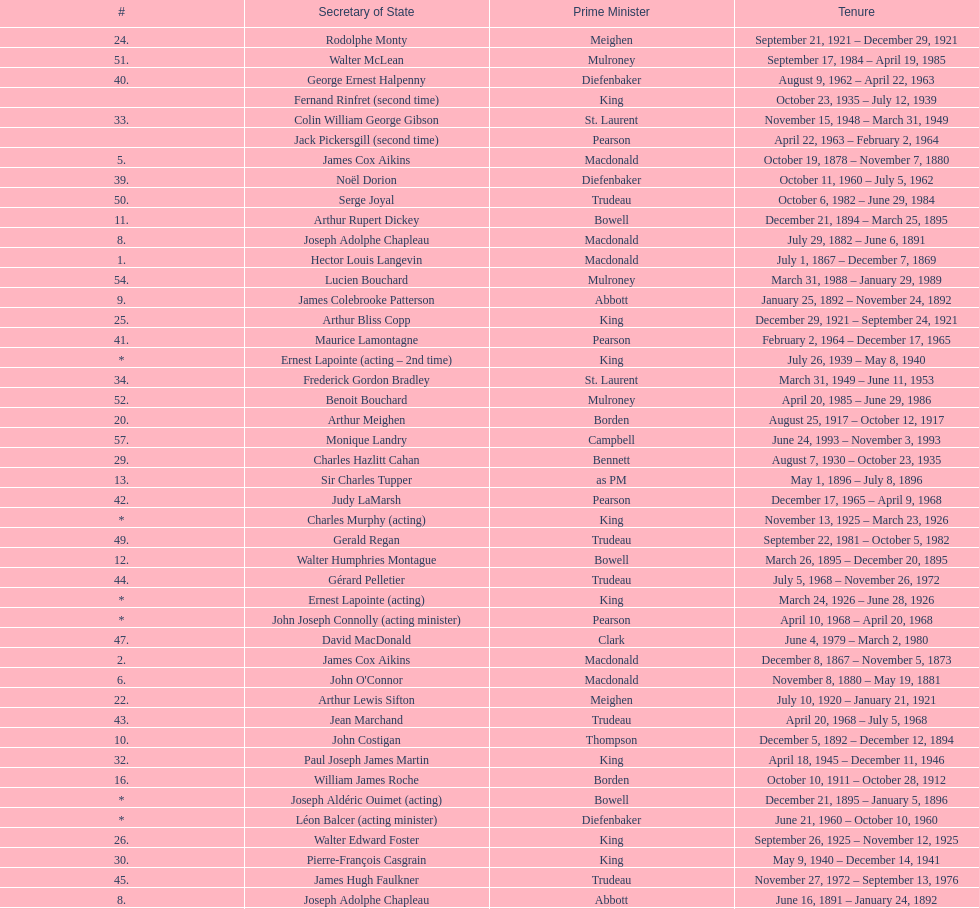Was macdonald prime minister before or after bowell? Before. 